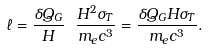<formula> <loc_0><loc_0><loc_500><loc_500>\ell = \frac { \delta Q _ { G } } { H } \ \frac { H ^ { 2 } \sigma _ { T } } { m _ { e } c ^ { 3 } } = \frac { \delta Q _ { G } H \sigma _ { T } } { m _ { e } c ^ { 3 } } .</formula> 